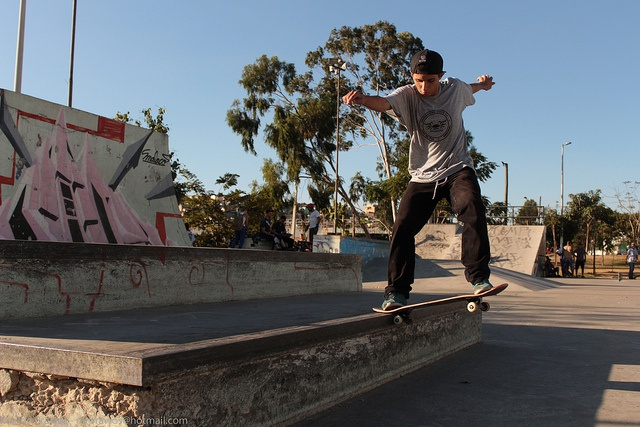Describe the objects in this image and their specific colors. I can see people in lightblue, black, gray, and maroon tones, skateboard in lightblue, black, gray, maroon, and tan tones, people in lightblue, black, maroon, gray, and tan tones, people in lightblue, black, maroon, and gray tones, and people in lightblue, black, and gray tones in this image. 